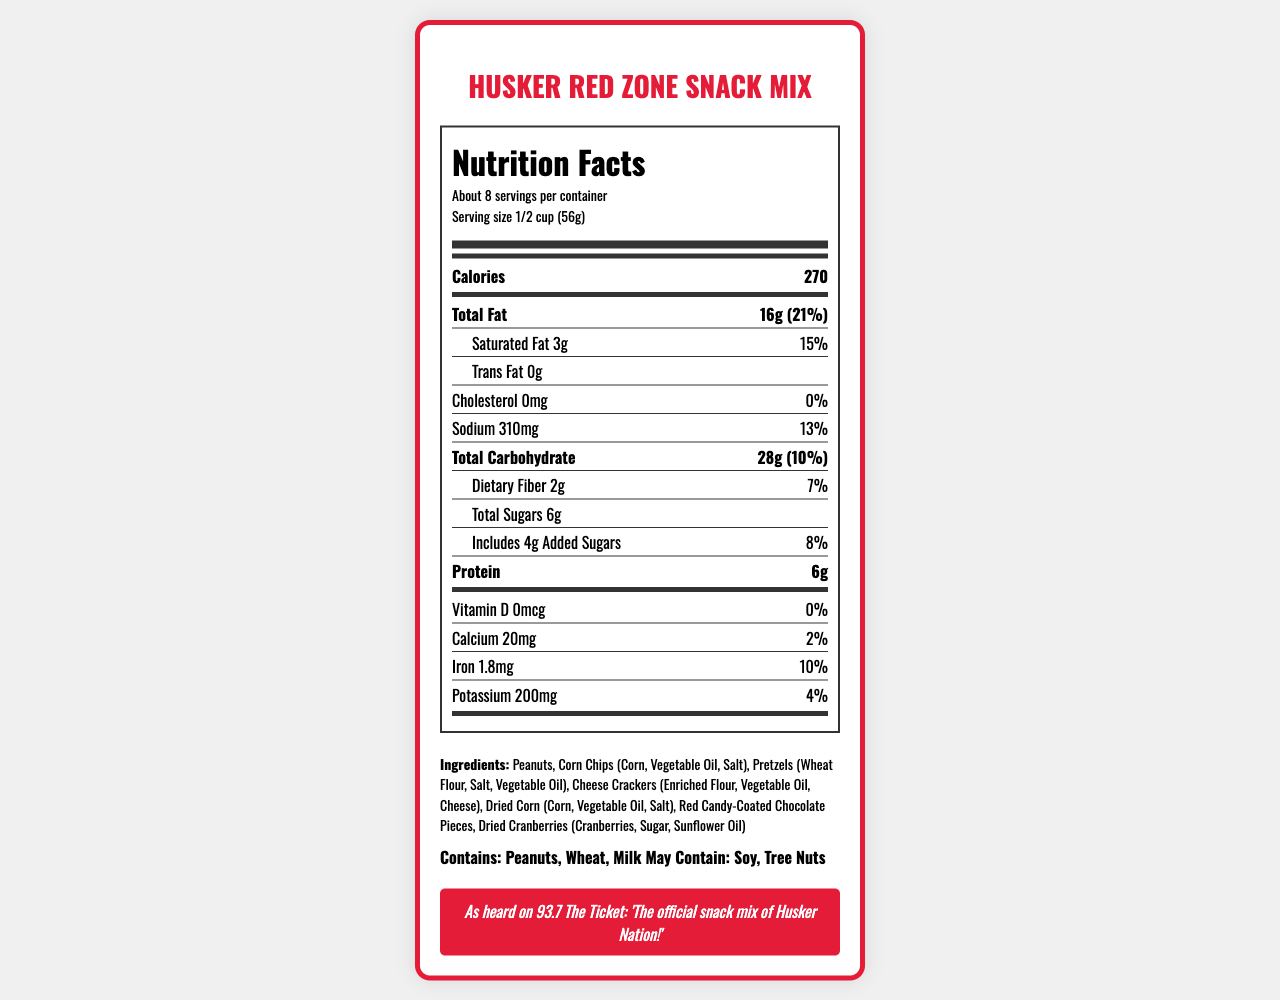what is the serving size for the Husker Red Zone Snack Mix? The serving size is listed under the serving information section as "1/2 cup (56g)."
Answer: 1/2 cup (56g) how many calories are in one serving? The calories per serving are displayed prominently in the nutrition label, next to the nutrient "Calories" as 270.
Answer: 270 what percent of the daily value for total fat does one serving provide? The total fat percentage is listed as "21%" next to the nutrient "Total Fat."
Answer: 21% which ingredients are listed in the Husker Red Zone Snack Mix? The ingredients are listed in the ingredients section as "Peanuts, Corn Chips (Corn, Vegetable Oil, Salt), Pretzels (Wheat Flour, Salt, Vegetable Oil), Cheese Crackers (Enriched Flour, Vegetable Oil, Cheese), Dried Corn (Corn, Vegetable Oil, Salt), Red Candy-Coated Chocolate Pieces, Dried Cranberries (Cranberries, Sugar, Sunflower Oil)."
Answer: Peanuts, Corn Chips, Pretzels, Cheese Crackers, Dried Corn, Red Candy-Coated Chocolate Pieces, Dried Cranberries does the snack mix contain any cholesterol? The nutrition label states that the cholesterol content is "0mg" with a daily value of "0%."
Answer: No what allergens are present in the snack mix? The allergens are listed in the allergen information section as "Contains: Peanuts, Wheat, Milk" and "May Contain: Soy, Tree Nuts."
Answer: Contains: Peanuts, Wheat, Milk; May Contain: Soy, Tree Nuts what is the main idea of the document? The document centers around presenting detailed nutritional information and ingredients for the Husker Red Zone Snack Mix, including serving size, calories, fat content, protein, vitamins, allergens, and special Nebraska-inspired elements.
Answer: The document provides the nutrition facts and ingredients for the Husker Red Zone Snack Mix, highlighting its nutritional content, allergen information, and fan-favorite status. what amount of sodium does one serving contain? A. 210mg B. 310mg C. 510mg D. 610mg The nutrition label states that the sodium content is "310mg" per serving.
Answer: B how many grams of dietary fiber are in each serving? A. 1g B. 2g C. 3g D. 4g The label lists "Dietary Fiber 2g" under the total carbohydrate section.
Answer: B is there any Trans Fat in the snack mix? The label specifically lists "Trans Fat 0g," indicating there is no trans fat in the snack mix.
Answer: No how much Vitamin D does one serving provide? The nutrition label shows "Vitamin D 0mcg" with a daily value of "0%."
Answer: 0mcg do both the red candy-coated chocolate pieces and cheese crackers contain added sugars? The document lists the ingredients but does not specify if the red candy-coated chocolate pieces and cheese crackers specifically contain added sugars.
Answer: Cannot be determined what is the slogan or tagline highlighted for the Husker Red Zone Snack Mix? The fan-favorite note section states: "As heard on 93.7 The Ticket: 'The official snack mix of Husker Nation!'"
Answer: 'The official snack mix of Husker Nation!' 